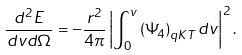<formula> <loc_0><loc_0><loc_500><loc_500>\frac { d ^ { 2 } E } { d v d \Omega } = - \frac { r ^ { 2 } } { 4 \pi } \left | \int ^ { v } _ { 0 } \left ( \Psi _ { 4 } \right ) _ { q K T } d v \right | ^ { 2 } .</formula> 